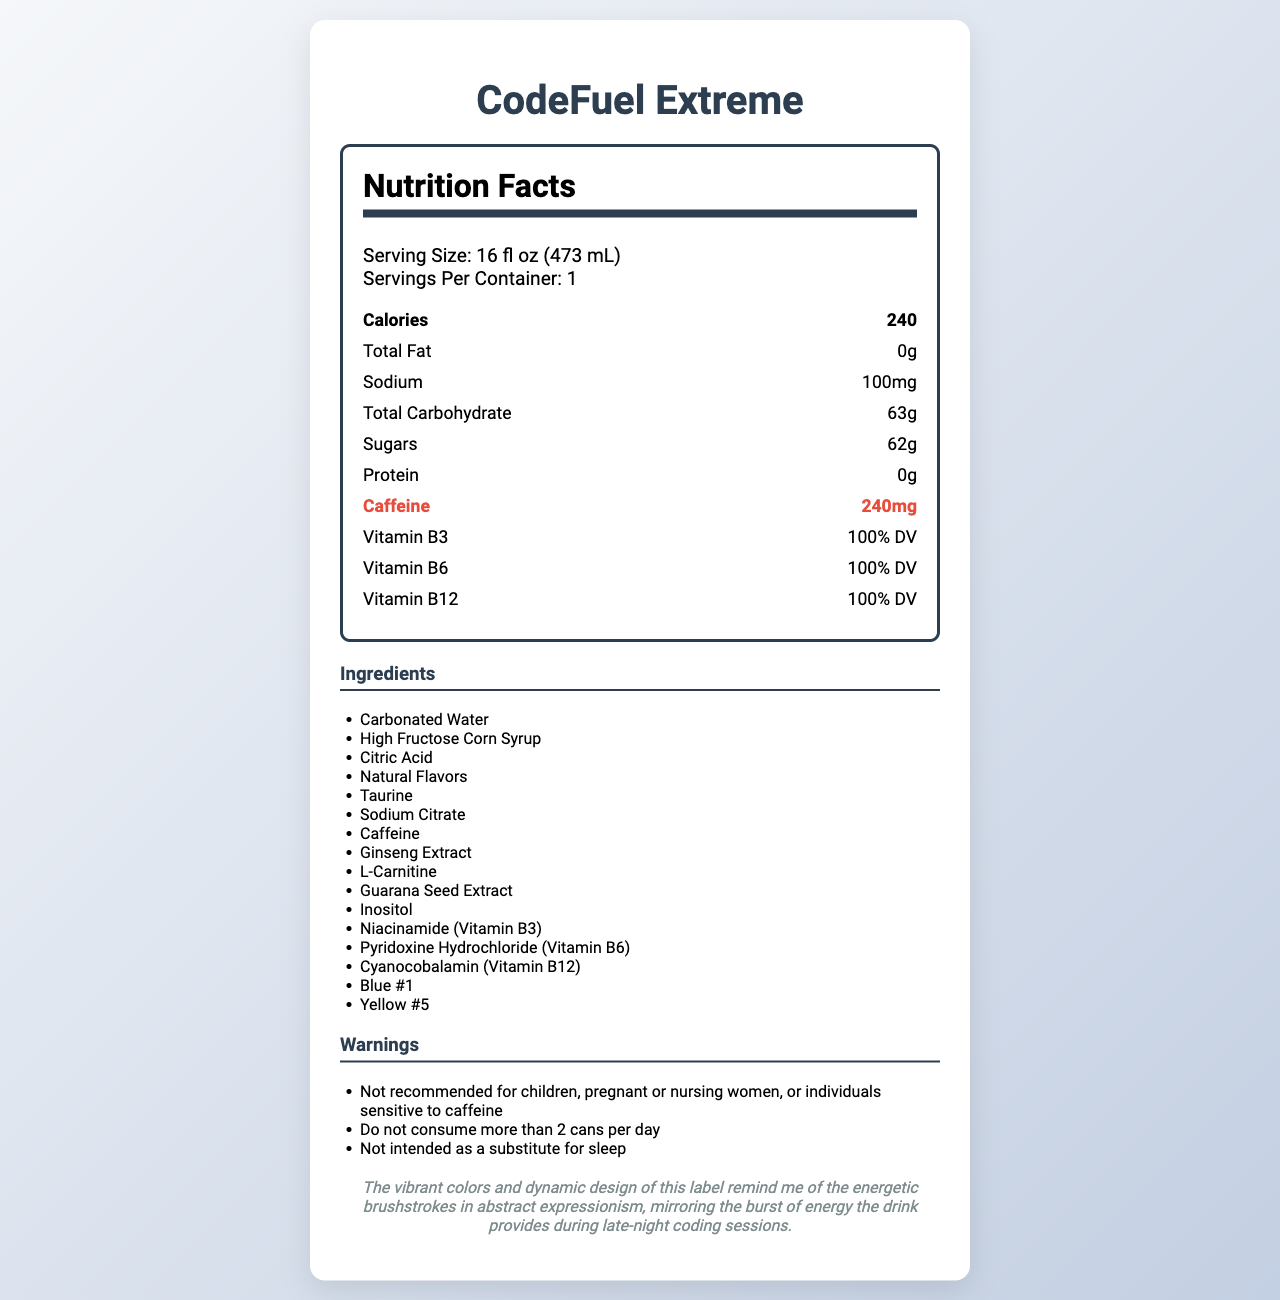What is the serving size of CodeFuel Extreme? The serving size is mentioned at the beginning of the Nutrition Facts section in the document.
Answer: 16 fl oz (473 mL) How many calories are in one serving of CodeFuel Extreme? The calories are listed as a separate item in the Nutrition Facts.
Answer: 240 What percentage of the daily value of Vitamin B6 is in CodeFuel Extreme? The Vitamin B6 percentage is stated in the Nutrition Facts section.
Answer: 100% DV How much caffeine is in a can of CodeFuel Extreme? The caffeine content is highlighted separately in the Nutrition Facts section, marked in red for emphasis.
Answer: 240mg List at least three active ingredients found in CodeFuel Extreme. These ingredients are listed under the Ingredients section.
Answer: Taurine, Ginseng Extract, L-Carnitine How many grams of sugars are present in CodeFuel Extreme? The sugars content is included in the Nutrition Facts section.
Answer: 62g What is the sodium content in one can of CodeFuel Extreme? The amount of sodium is listed in the Nutrition Facts section.
Answer: 100mg Which vitamins are highlighted in CodeFuel Extreme's nutrition label? (Select all that apply)  
A. Vitamin A  
B. Vitamin B3  
C. Vitamin C  
D. Vitamin B6  
E. Vitamin B12 The Nutrition Facts section mentions Vitamin B3, Vitamin B6, and Vitamin B12, all at 100% DV.
Answer: B, D, E Which of the following statements is true about the total carbohydrate content in CodeFuel Extreme?  
I. It contains 63g of total carbohydrate.  
II. It contains 62g of total carbohydrate.  
III. It contains 63g of sugars. The Nutrition Facts section states that the total carbohydrate content is 63g.
Answer: I Does the label indicate any common allergens in CodeFuel Extreme? According to the allergen information section, the product contains no common allergens.
Answer: No Is CodeFuel Extreme suitable for children? The warnings section clearly states that it is not recommended for children.
Answer: No Summarize the main information presented in the CodeFuel Extreme Nutrition Facts Label. The document provides detailed nutritional information, ingredients, and warnings about consuming CodeFuel Extreme, emphasizing its high caffeine and sugar content, as well as its vitamin contributions.
Answer: CodeFuel Extreme is an energy drink with 240 calories, 62g of sugars, and 240mg of caffeine per 16 fl oz serving. It contains 100% DV of Vitamins B3, B6, and B12, along with taurine, ginseng extract, L-carnitine, guarana seed extract, and inositol. The label also includes warnings about its high caffeine content and advises against consumption by children and certain other individuals. How much L-carnitine is included in CodeFuel Extreme? The amount of L-carnitine is listed under the Nutrition Facts section.
Answer: 500mg Can the total fat content in CodeFuel Extreme change based on dietary preferences? The document provides the total fat content, but it does not offer information about variability due to dietary preferences.
Answer: Cannot be determined 